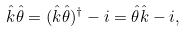Convert formula to latex. <formula><loc_0><loc_0><loc_500><loc_500>\hat { k } \hat { \theta } = ( \hat { k } \hat { \theta } ) ^ { \dagger } - i = \hat { \theta } \hat { k } - i ,</formula> 